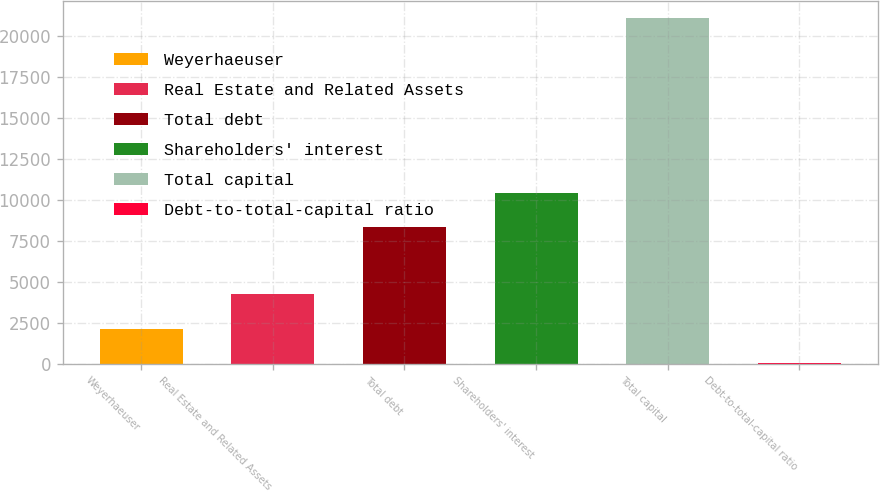<chart> <loc_0><loc_0><loc_500><loc_500><bar_chart><fcel>Weyerhaeuser<fcel>Real Estate and Related Assets<fcel>Total debt<fcel>Shareholders' interest<fcel>Total capital<fcel>Debt-to-total-capital ratio<nl><fcel>2140.36<fcel>4241.32<fcel>8303<fcel>10404<fcel>21049<fcel>39.4<nl></chart> 